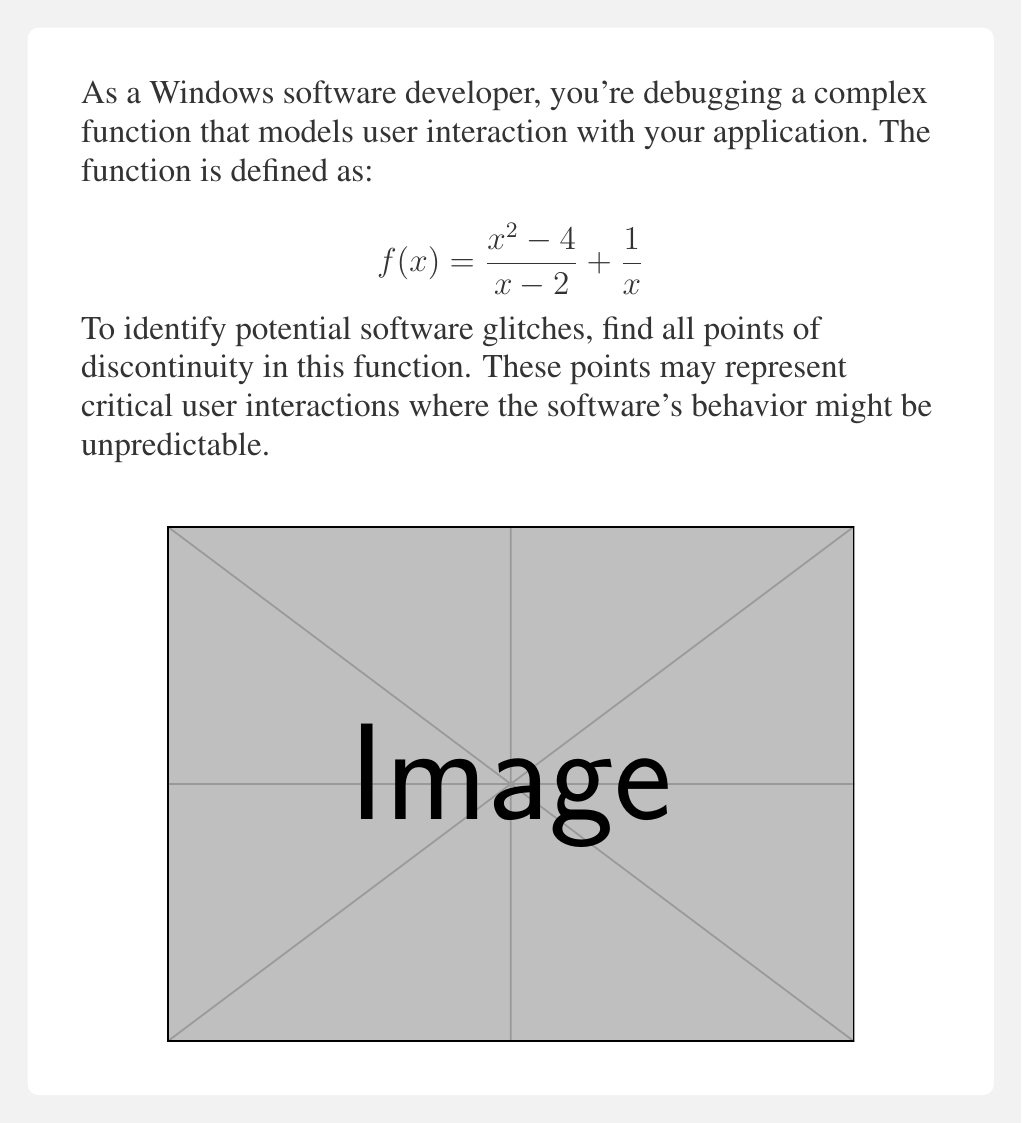Can you answer this question? To find the points of discontinuity, we need to examine where the function is undefined or where it has a jump discontinuity. Let's approach this step-by-step:

1) First, let's look at the domain of each part of the function:
   a) For $\frac{x^2 - 4}{x - 2}$, x ≠ 2
   b) For $\frac{1}{x}$, x ≠ 0

2) Now, let's examine x = 2:
   $$\lim_{x \to 2} \frac{x^2 - 4}{x - 2} = \lim_{x \to 2} \frac{(x+2)(x-2)}{x-2} = \lim_{x \to 2} (x+2) = 4$$
   However, $\frac{1}{2}$ is defined, so we need to check if there's a jump discontinuity.
   $$\lim_{x \to 2} f(x) = 4 + \frac{1}{2} = \frac{9}{2}$$
   This limit exists, but f(2) is undefined. Therefore, x = 2 is a point of discontinuity (removable).

3) For x = 0:
   $\lim_{x \to 0} \frac{x^2 - 4}{x - 2} = 2$, but $\lim_{x \to 0} \frac{1}{x}$ does not exist.
   Therefore, x = 0 is a point of discontinuity (infinite).

These points of discontinuity (x = 0 and x = 2) represent potential areas in your software where user interactions might lead to unexpected behavior or glitches.
Answer: x = 0 and x = 2 